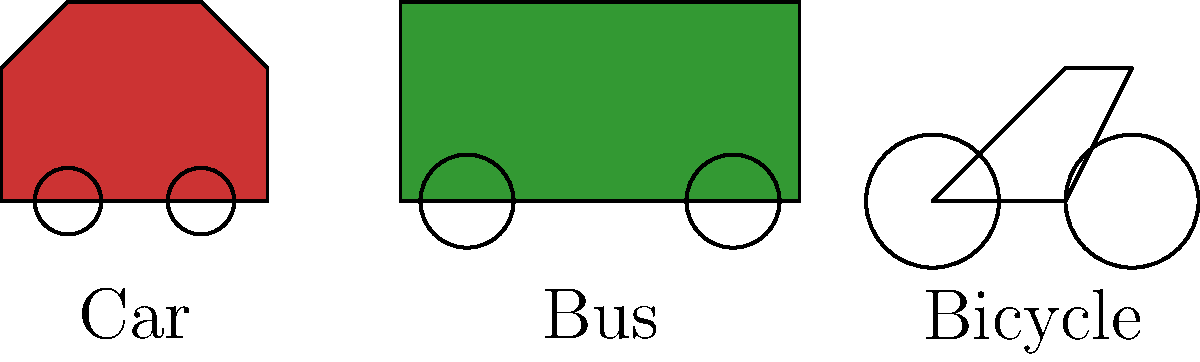Look at the image showing three different types of transportation. Which vehicle is the longest and can carry the most passengers? Let's analyze the image step-by-step:

1. We can see three different vehicles in the image: a car, a bus, and a bicycle.

2. The car is shown on the left side. It's relatively small and can typically carry 4-5 passengers.

3. The bus is in the middle. It's the largest vehicle in the image, with a long rectangular shape. Buses are designed to carry many passengers, usually between 30-60 people depending on the size.

4. The bicycle is on the right side. It's the smallest vehicle and typically carries only one person, or sometimes two.

5. Comparing the sizes, we can clearly see that the bus is the longest vehicle in the image.

6. Based on our knowledge of these vehicles, we know that buses are specifically designed for public transportation and can carry the most passengers among these three options.

Therefore, the bus is both the longest vehicle and the one that can carry the most passengers.
Answer: Bus 